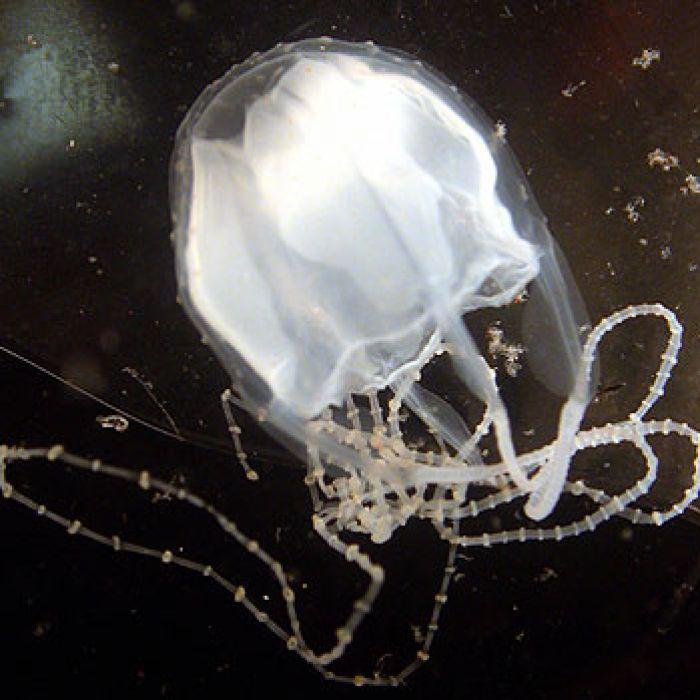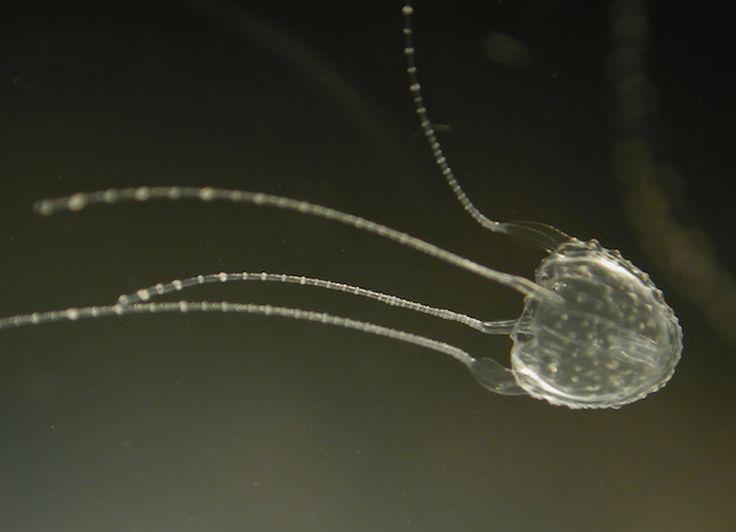The first image is the image on the left, the second image is the image on the right. For the images displayed, is the sentence "The jellyfish on the right is blue and has four tentacles." factually correct? Answer yes or no. No. 